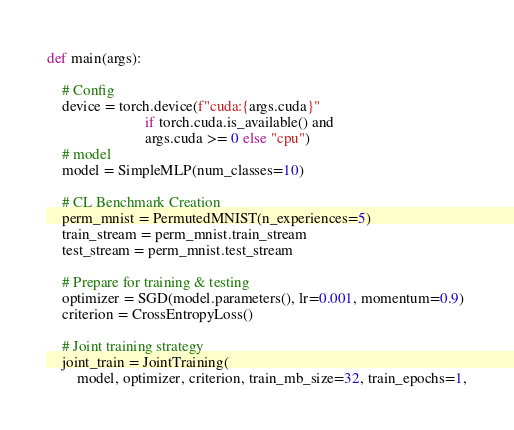<code> <loc_0><loc_0><loc_500><loc_500><_Python_>

def main(args):

    # Config
    device = torch.device(f"cuda:{args.cuda}"
                          if torch.cuda.is_available() and
                          args.cuda >= 0 else "cpu")
    # model
    model = SimpleMLP(num_classes=10)

    # CL Benchmark Creation
    perm_mnist = PermutedMNIST(n_experiences=5)
    train_stream = perm_mnist.train_stream
    test_stream = perm_mnist.test_stream

    # Prepare for training & testing
    optimizer = SGD(model.parameters(), lr=0.001, momentum=0.9)
    criterion = CrossEntropyLoss()

    # Joint training strategy
    joint_train = JointTraining(
        model, optimizer, criterion, train_mb_size=32, train_epochs=1,</code> 